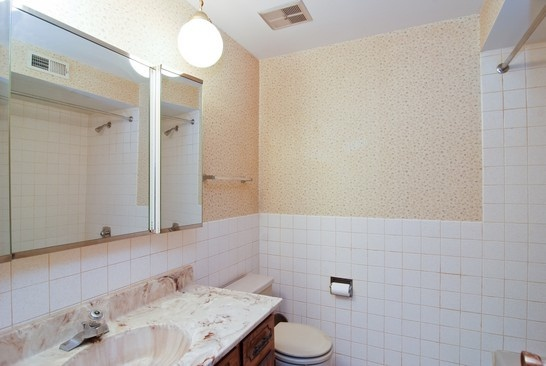Describe the objects in this image and their specific colors. I can see sink in white, darkgray, and lightgray tones and toilet in white, darkgray, gray, and black tones in this image. 